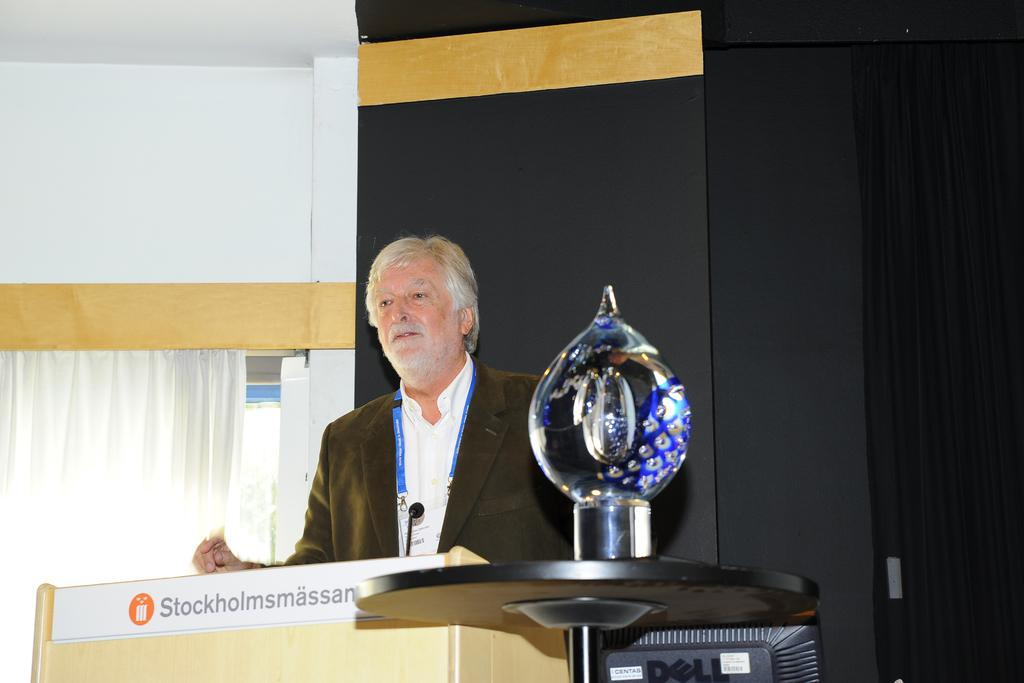What is the man in the image doing? The man is standing in the image. What is in front of the man? There is a microphone with a podium in front of the man. What can be seen on the table in the image? There is an object on the table. What is visible in the background of the image? The background of the image includes a curtain and a wall. Can you see a basket on the man's nose in the image? No, there is no basket on the man's nose in the image. Is there a baby present in the image? No, there is no baby present in the image. 